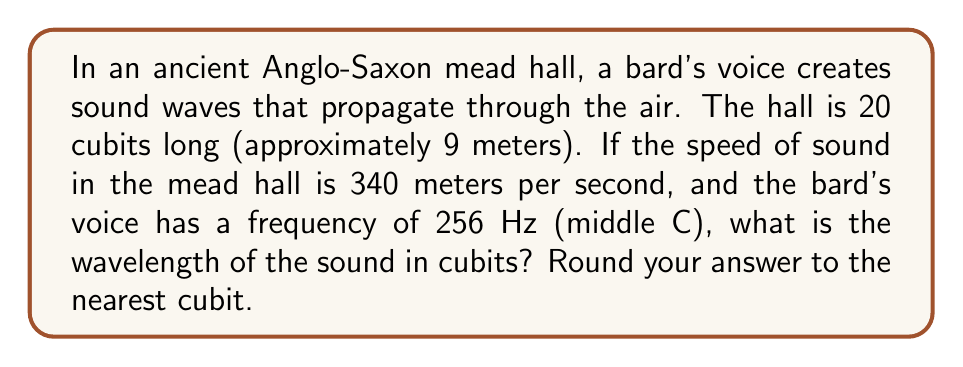Show me your answer to this math problem. To solve this problem, we'll use the wave equation:

$$v = f \lambda$$

Where:
$v$ = speed of sound
$f$ = frequency
$\lambda$ = wavelength

1. Convert the given values to consistent units:
   - Speed of sound: $v = 340$ m/s
   - Frequency: $f = 256$ Hz
   - 1 cubit ≈ 0.45 meters

2. Rearrange the wave equation to solve for wavelength:

   $$\lambda = \frac{v}{f}$$

3. Substitute the known values:

   $$\lambda = \frac{340 \text{ m/s}}{256 \text{ Hz}} = 1.328125 \text{ m}$$

4. Convert the wavelength from meters to cubits:

   $$\lambda_{\text{cubits}} = \frac{1.328125 \text{ m}}{0.45 \text{ m/cubit}} = 2.95 \text{ cubits}$$

5. Round to the nearest cubit:

   $$\lambda_{\text{cubits}} \approx 3 \text{ cubits}$$
Answer: 3 cubits 